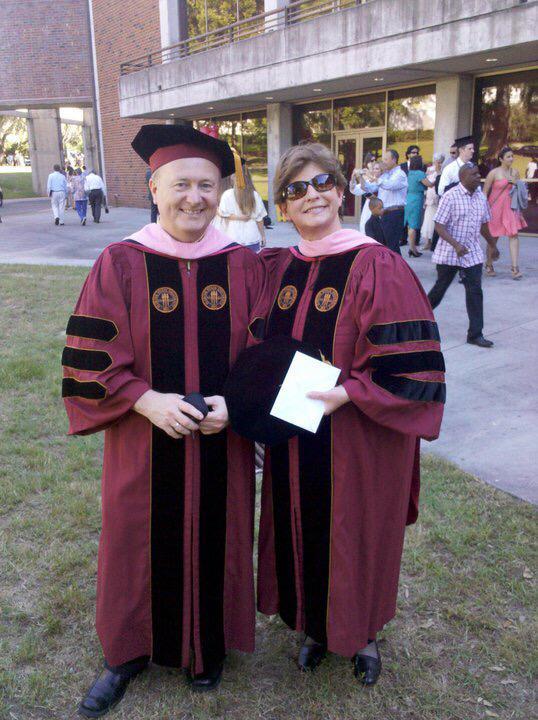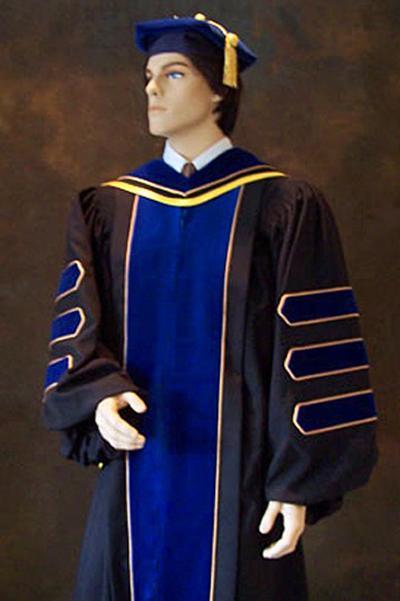The first image is the image on the left, the second image is the image on the right. Considering the images on both sides, is "Two people pose together outside wearing graduation attire in one of the images." valid? Answer yes or no. Yes. The first image is the image on the left, the second image is the image on the right. For the images shown, is this caption "The left image shows a round-faced man with mustache and beard wearing a graduation robe and gold-tasseled cap, and the right image shows people in different colored robes with stripes on the sleeves." true? Answer yes or no. No. 